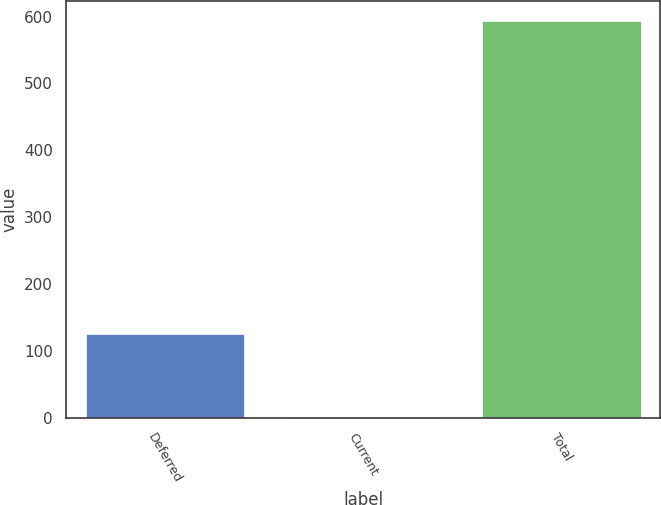Convert chart to OTSL. <chart><loc_0><loc_0><loc_500><loc_500><bar_chart><fcel>Deferred<fcel>Current<fcel>Total<nl><fcel>125<fcel>1<fcel>593<nl></chart> 